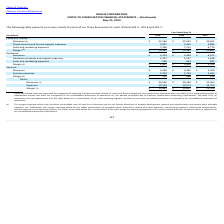Looking at Oracle Corporation's financial data, please calculate: What was the percentage change in hardware revenues from 2017 to 2018? To answer this question, I need to perform calculations using the financial data. The calculation is: (3,994-4,152)/4,152 , which equals -3.81 (percentage). This is based on the information: "revenues $ 3,704 $ 3,994 $ 4,152 revenues $ 3,704 $ 3,994 $ 4,152..." The key data points involved are: 3,994, 4,152. Also, can you calculate: How much was the total revenue for cloud and license business and services business in 2019? Based on the calculation: 3,240+32,582 , the result is 35822 (in millions). This is based on the information: "revenues (1) $ 32,582 $ 32,041 $ 30,452 revenues $ 3,240 $ 3,395 $ 3,359..." The key data points involved are: 3,240, 32,582. Also, can you calculate: What was the difference in total expenses in 2019 and 2017? Based on the calculation: 15,545 - 14,755 , the result is 790 (in millions). This is based on the information: "Expenses 15,545 15,573 14,755 Expenses 15,545 15,573 14,755..." The key data points involved are: 14,755, 15,545. Also, Do the margins reported reflect amortization of intangible assets? Additionally, the margins reported above do not reflect amortization of intangible assets. The document states: "rative and certain other allocable expenses, net. Additionally, the margins reported above do not reflect amortization of intangible assets, acquisiti..." Also, Why were revenues related to cloud and license obligations not recognized in the consolidated statements of operations for the periods presented? Cloud and license revenues presented for management reporting included revenues related to cloud and license obligations that would have otherwise been recorded by the acquired businesses as independent entities but were not recognized in our consolidated statements of operations for the periods presented due to business combination accounting requirements. The document states: "(1) Cloud and license revenues presented for management reporting included revenues related to cloud and license obligations that would have otherwise..." Also, Which note can one refer to for an explanation of adjustments made? See Note 9 for an explanation of these adjustments and the table below for a reconciliation of our total operating segment revenues to our total consolidated revenues as reported in our consolidated statements of operations. The document states: "to business combination accounting requirements. See Note 9 for an explanation of these adjustments and the table below for a reconciliation of our to..." 